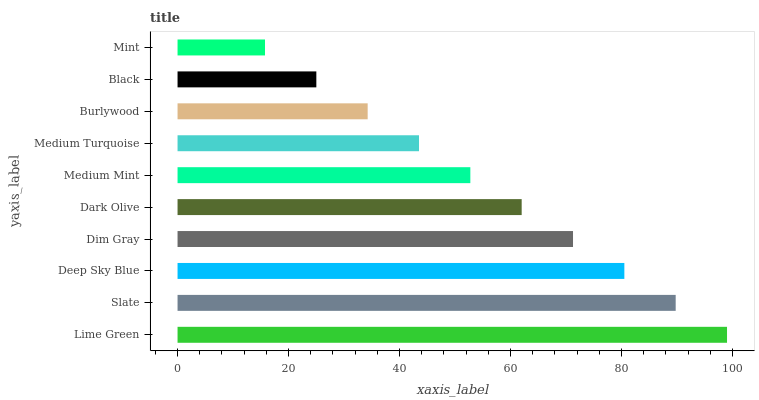Is Mint the minimum?
Answer yes or no. Yes. Is Lime Green the maximum?
Answer yes or no. Yes. Is Slate the minimum?
Answer yes or no. No. Is Slate the maximum?
Answer yes or no. No. Is Lime Green greater than Slate?
Answer yes or no. Yes. Is Slate less than Lime Green?
Answer yes or no. Yes. Is Slate greater than Lime Green?
Answer yes or no. No. Is Lime Green less than Slate?
Answer yes or no. No. Is Dark Olive the high median?
Answer yes or no. Yes. Is Medium Mint the low median?
Answer yes or no. Yes. Is Mint the high median?
Answer yes or no. No. Is Lime Green the low median?
Answer yes or no. No. 